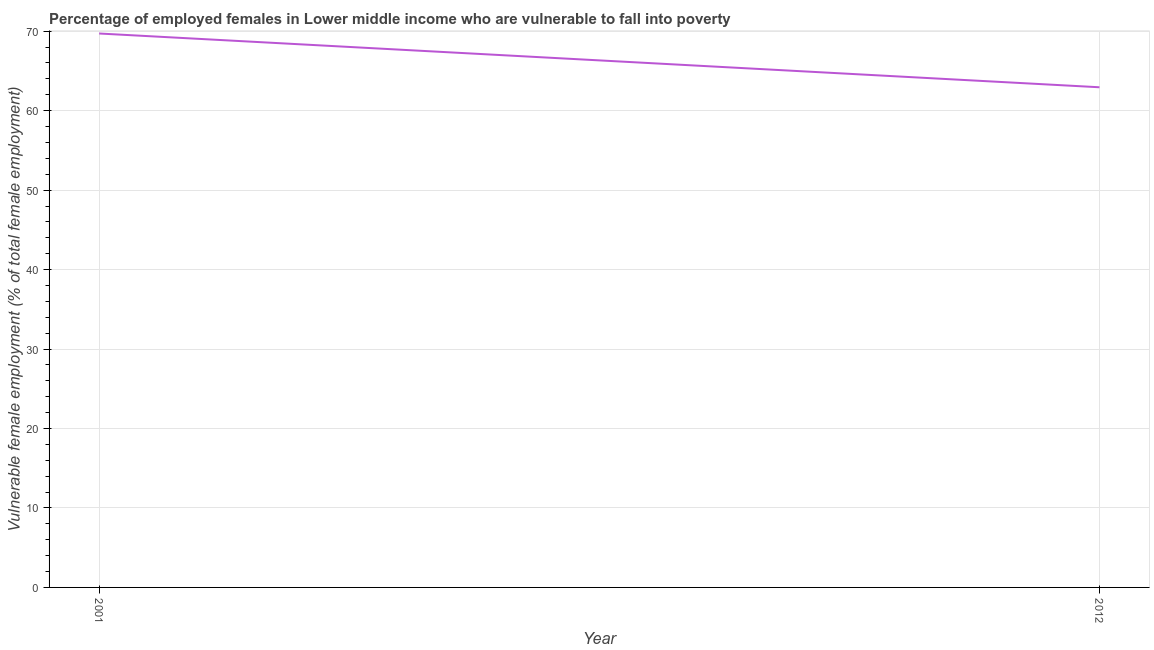What is the percentage of employed females who are vulnerable to fall into poverty in 2001?
Your answer should be very brief. 69.71. Across all years, what is the maximum percentage of employed females who are vulnerable to fall into poverty?
Offer a very short reply. 69.71. Across all years, what is the minimum percentage of employed females who are vulnerable to fall into poverty?
Keep it short and to the point. 62.94. What is the sum of the percentage of employed females who are vulnerable to fall into poverty?
Your answer should be compact. 132.65. What is the difference between the percentage of employed females who are vulnerable to fall into poverty in 2001 and 2012?
Make the answer very short. 6.77. What is the average percentage of employed females who are vulnerable to fall into poverty per year?
Give a very brief answer. 66.33. What is the median percentage of employed females who are vulnerable to fall into poverty?
Ensure brevity in your answer.  66.33. In how many years, is the percentage of employed females who are vulnerable to fall into poverty greater than 28 %?
Your answer should be very brief. 2. Do a majority of the years between 2001 and 2012 (inclusive) have percentage of employed females who are vulnerable to fall into poverty greater than 64 %?
Make the answer very short. No. What is the ratio of the percentage of employed females who are vulnerable to fall into poverty in 2001 to that in 2012?
Ensure brevity in your answer.  1.11. Is the percentage of employed females who are vulnerable to fall into poverty in 2001 less than that in 2012?
Your response must be concise. No. How many lines are there?
Provide a succinct answer. 1. What is the title of the graph?
Keep it short and to the point. Percentage of employed females in Lower middle income who are vulnerable to fall into poverty. What is the label or title of the X-axis?
Provide a short and direct response. Year. What is the label or title of the Y-axis?
Your answer should be very brief. Vulnerable female employment (% of total female employment). What is the Vulnerable female employment (% of total female employment) in 2001?
Your answer should be very brief. 69.71. What is the Vulnerable female employment (% of total female employment) in 2012?
Offer a terse response. 62.94. What is the difference between the Vulnerable female employment (% of total female employment) in 2001 and 2012?
Keep it short and to the point. 6.77. What is the ratio of the Vulnerable female employment (% of total female employment) in 2001 to that in 2012?
Your response must be concise. 1.11. 